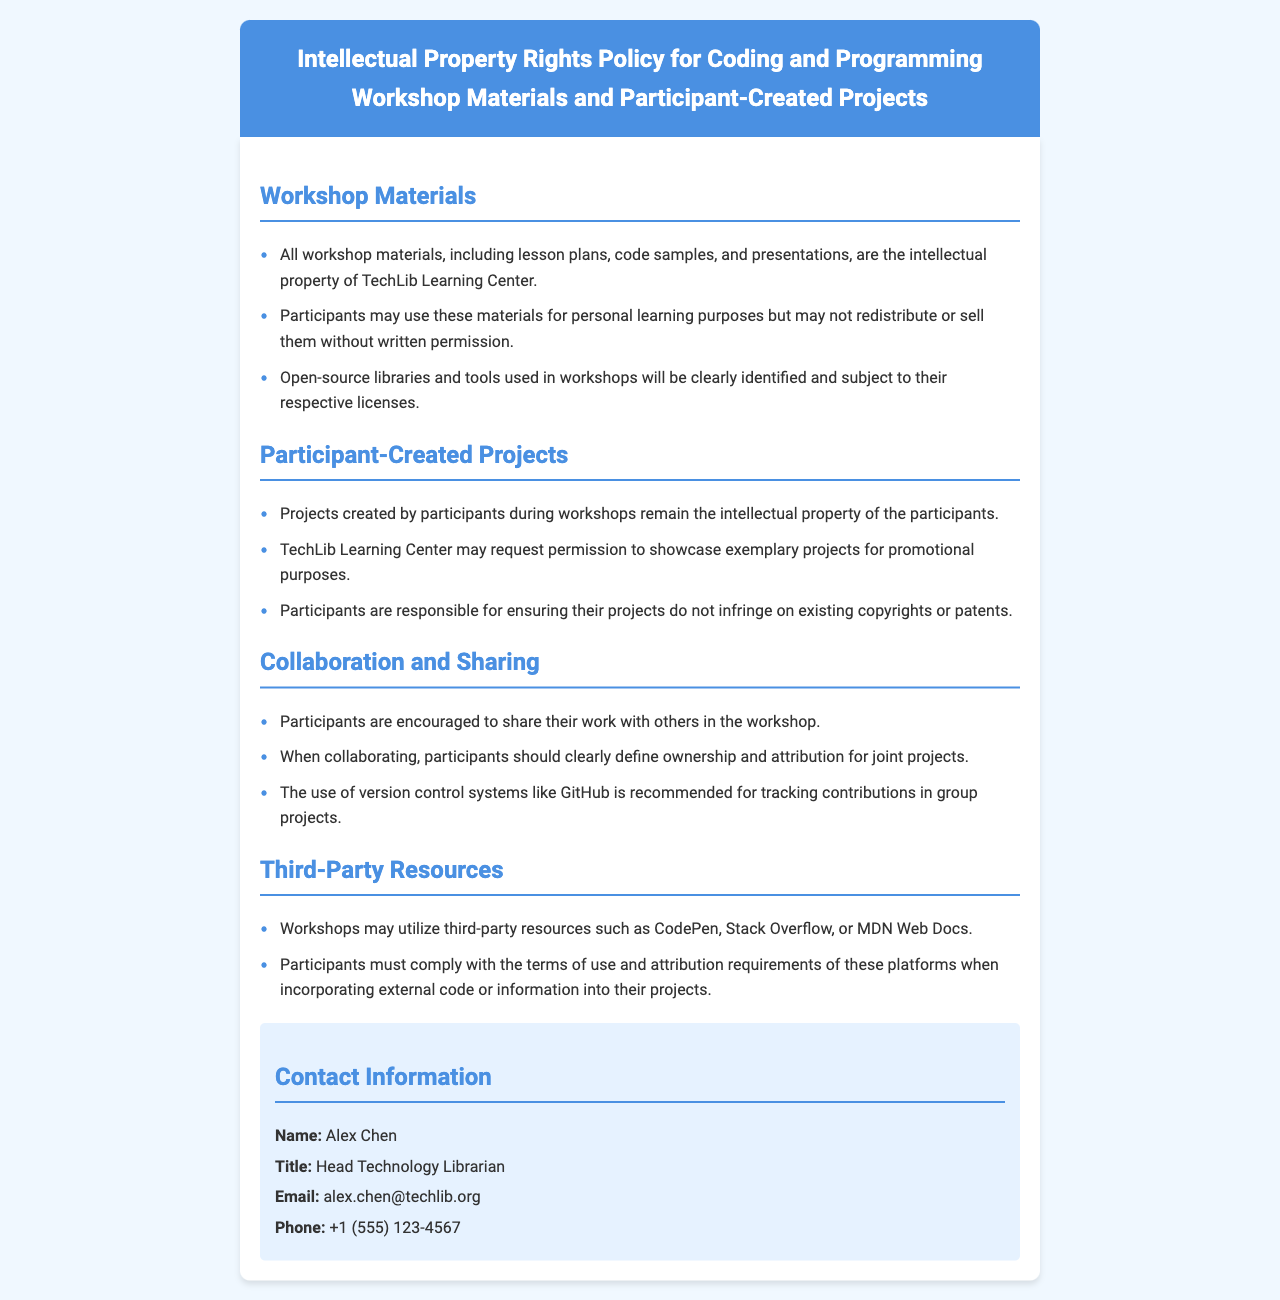What is the title of the policy document? The title is specified in the header section of the document.
Answer: Intellectual Property Rights Policy for Coding and Programming Workshop Materials and Participant-Created Projects Who is the Head Technology Librarian? The contact information section provides the name of the Head Technology Librarian.
Answer: Alex Chen What must participants do if they want to redistribute workshop materials? This information is found under the section about workshop materials regarding use of the materials.
Answer: Written permission What is recommended for tracking contributions in group projects? This is specified in the collaboration section of the document.
Answer: Version control systems like GitHub What type of projects remain the intellectual property of the participants? This detail is outlined in the section about participant-created projects.
Answer: Projects created by participants during workshops How should participants handle third-party resources used in workshops? The section on third-party resources outlines the participant's responsibilities.
Answer: Comply with the terms of use and attribution requirements What is the purpose of the TechLib Learning Center's request regarding participant projects? This can be found in the section discussing participant-created projects and their showcasing.
Answer: Promotional purposes What is required for joint projects during collaboration? The collaboration section clarifies the need for certain guidelines when working together.
Answer: Clearly define ownership and attribution 